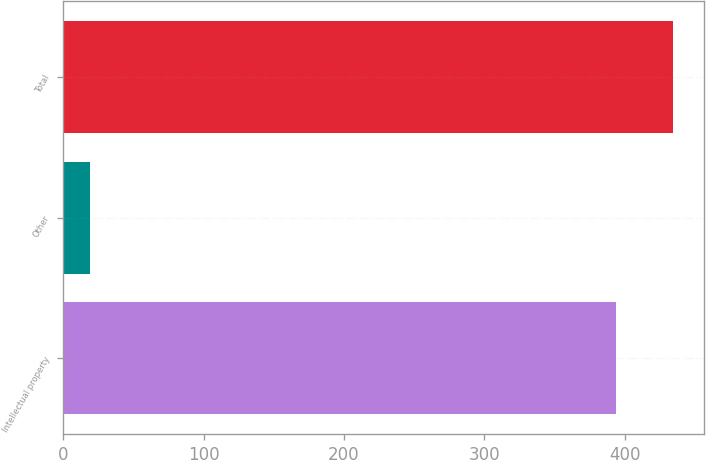Convert chart to OTSL. <chart><loc_0><loc_0><loc_500><loc_500><bar_chart><fcel>Intellectual property<fcel>Other<fcel>Total<nl><fcel>394<fcel>19<fcel>434.7<nl></chart> 